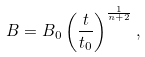Convert formula to latex. <formula><loc_0><loc_0><loc_500><loc_500>B = B _ { 0 } \left ( \frac { t } { t _ { 0 } } \right ) ^ { \frac { 1 } { n + 2 } } ,</formula> 